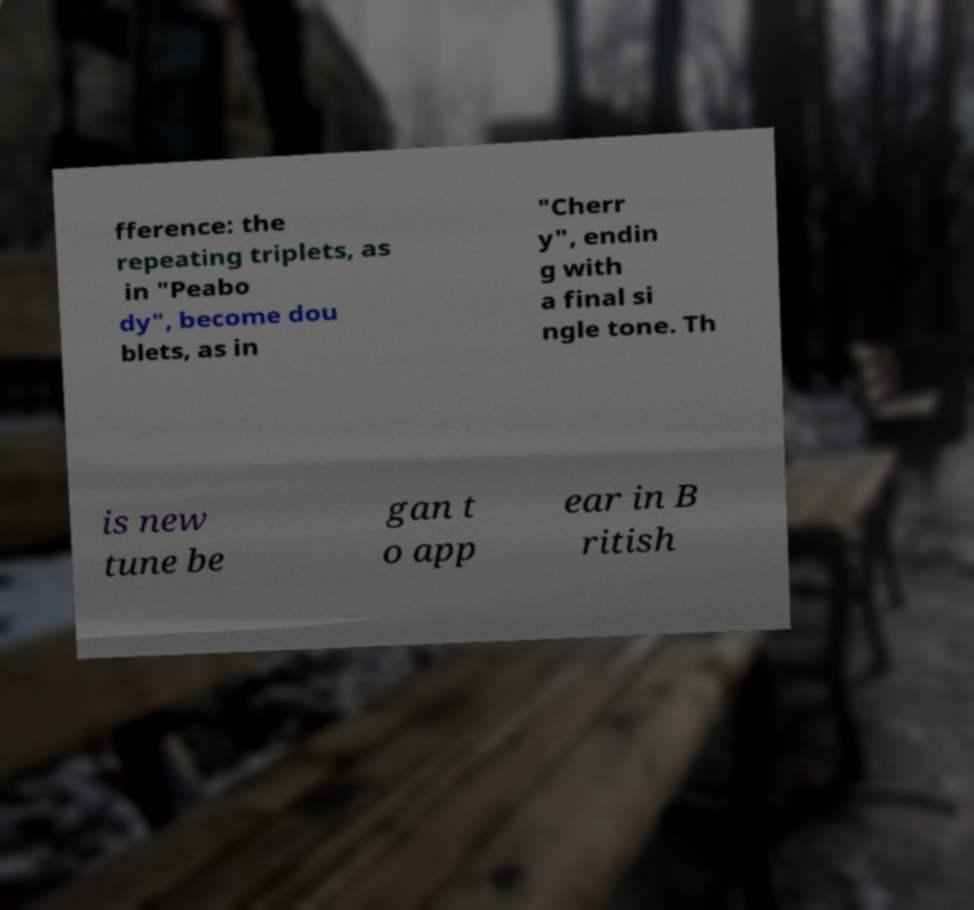Please read and relay the text visible in this image. What does it say? fference: the repeating triplets, as in "Peabo dy", become dou blets, as in "Cherr y", endin g with a final si ngle tone. Th is new tune be gan t o app ear in B ritish 